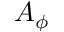<formula> <loc_0><loc_0><loc_500><loc_500>A _ { \phi }</formula> 